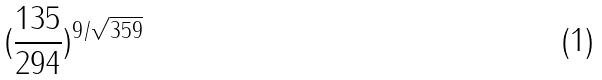<formula> <loc_0><loc_0><loc_500><loc_500>( \frac { 1 3 5 } { 2 9 4 } ) ^ { 9 / \sqrt { 3 5 9 } }</formula> 